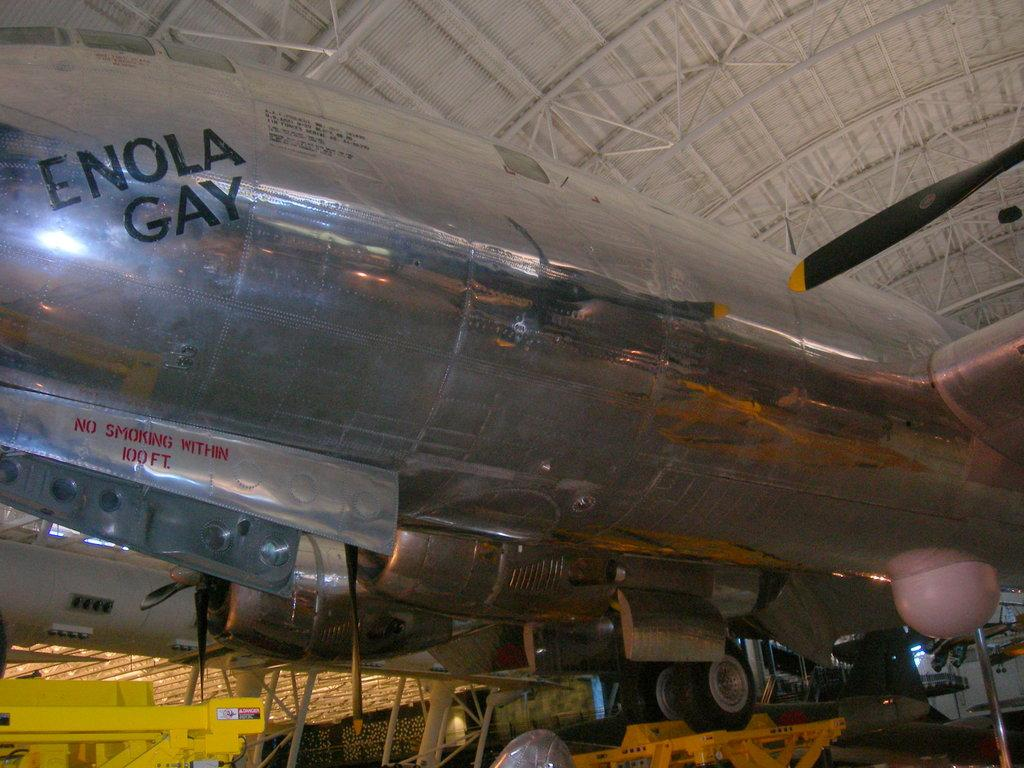<image>
Render a clear and concise summary of the photo. The big silver plane is called the Enola Gay 